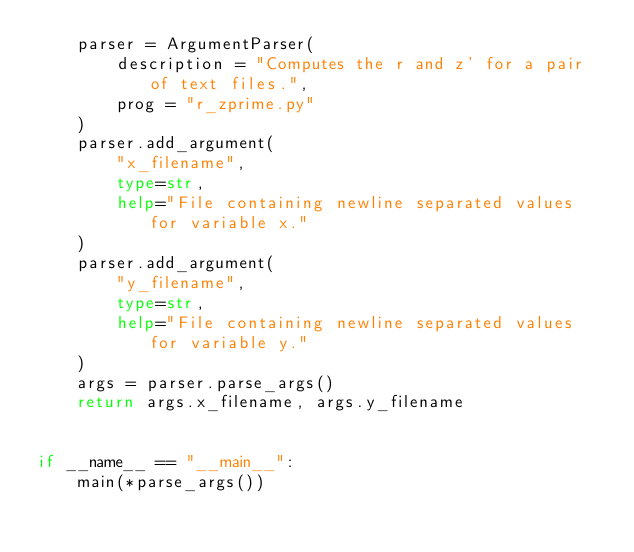<code> <loc_0><loc_0><loc_500><loc_500><_Python_>	parser = ArgumentParser(
		description = "Computes the r and z' for a pair of text files.",
		prog = "r_zprime.py"
	)
	parser.add_argument(
		"x_filename",
		type=str,
		help="File containing newline separated values for variable x."
	)
	parser.add_argument(
		"y_filename",
		type=str,
		help="File containing newline separated values for variable y."
	)
	args = parser.parse_args()
	return args.x_filename, args.y_filename


if __name__ == "__main__":
	main(*parse_args())
</code> 